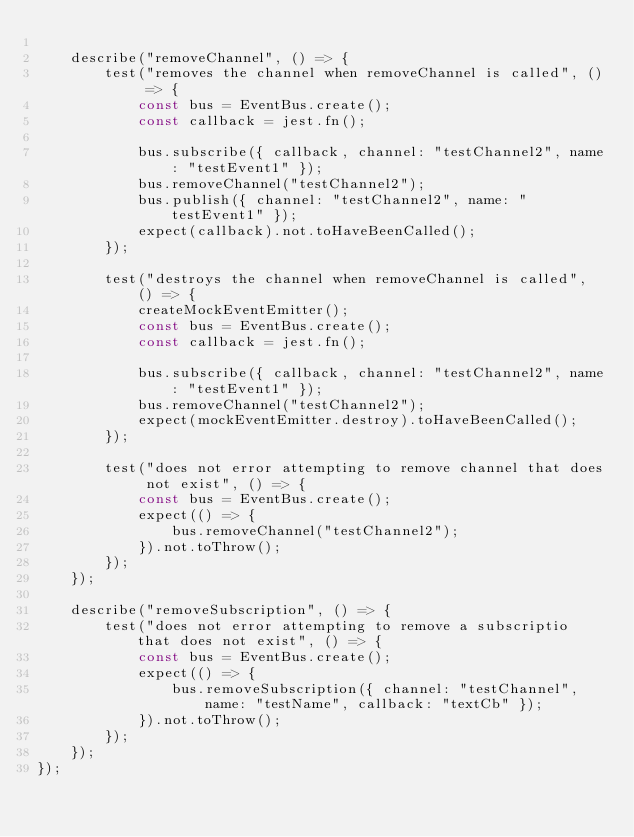<code> <loc_0><loc_0><loc_500><loc_500><_JavaScript_>
	describe("removeChannel", () => {
		test("removes the channel when removeChannel is called", () => {
			const bus = EventBus.create();
			const callback = jest.fn();

			bus.subscribe({ callback, channel: "testChannel2", name: "testEvent1" });
			bus.removeChannel("testChannel2");
			bus.publish({ channel: "testChannel2", name: "testEvent1" });
			expect(callback).not.toHaveBeenCalled();
		});

		test("destroys the channel when removeChannel is called", () => {
			createMockEventEmitter();
			const bus = EventBus.create();
			const callback = jest.fn();

			bus.subscribe({ callback, channel: "testChannel2", name: "testEvent1" });
			bus.removeChannel("testChannel2");
			expect(mockEventEmitter.destroy).toHaveBeenCalled();
		});

		test("does not error attempting to remove channel that does not exist", () => {
			const bus = EventBus.create();
			expect(() => {
				bus.removeChannel("testChannel2");
			}).not.toThrow();
		});
	});

	describe("removeSubscription", () => {
		test("does not error attempting to remove a subscriptio that does not exist", () => {
			const bus = EventBus.create();
			expect(() => {
				bus.removeSubscription({ channel: "testChannel", name: "testName", callback: "textCb" });
			}).not.toThrow();
		});
	});
});
</code> 